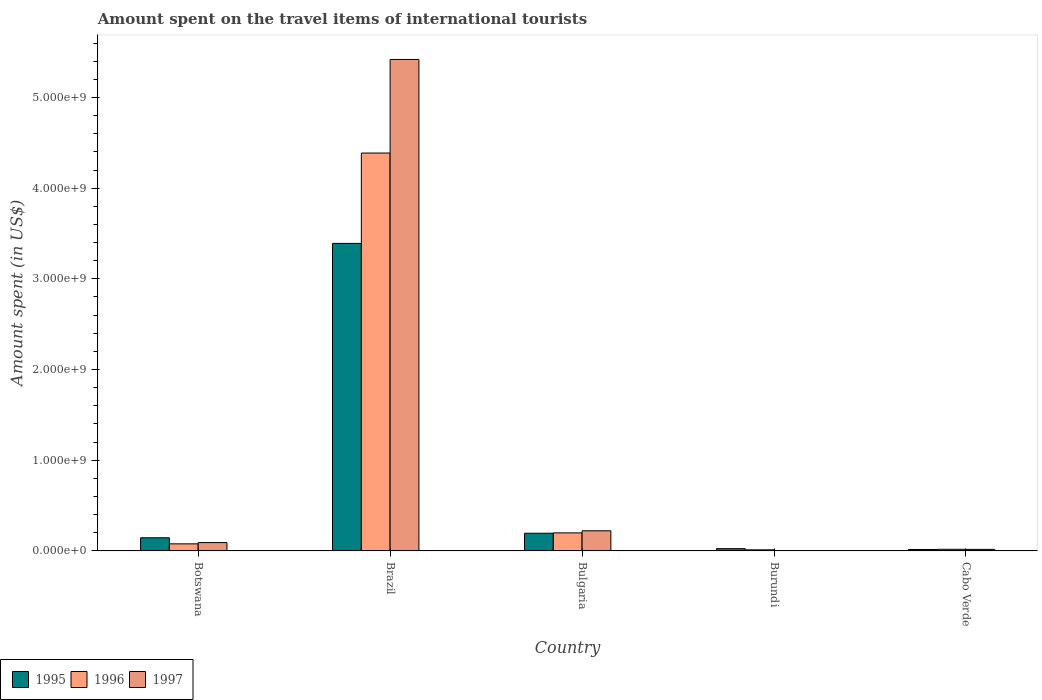How many different coloured bars are there?
Your answer should be very brief. 3. Are the number of bars on each tick of the X-axis equal?
Make the answer very short. Yes. What is the label of the 2nd group of bars from the left?
Ensure brevity in your answer.  Brazil. In how many cases, is the number of bars for a given country not equal to the number of legend labels?
Ensure brevity in your answer.  0. What is the amount spent on the travel items of international tourists in 1996 in Botswana?
Your answer should be compact. 7.80e+07. Across all countries, what is the maximum amount spent on the travel items of international tourists in 1995?
Your response must be concise. 3.39e+09. Across all countries, what is the minimum amount spent on the travel items of international tourists in 1995?
Provide a succinct answer. 1.60e+07. In which country was the amount spent on the travel items of international tourists in 1996 minimum?
Offer a terse response. Burundi. What is the total amount spent on the travel items of international tourists in 1997 in the graph?
Offer a very short reply. 5.75e+09. What is the difference between the amount spent on the travel items of international tourists in 1996 in Botswana and that in Bulgaria?
Your response must be concise. -1.21e+08. What is the difference between the amount spent on the travel items of international tourists in 1996 in Bulgaria and the amount spent on the travel items of international tourists in 1995 in Botswana?
Ensure brevity in your answer.  5.40e+07. What is the average amount spent on the travel items of international tourists in 1996 per country?
Your response must be concise. 9.39e+08. What is the difference between the amount spent on the travel items of international tourists of/in 1995 and amount spent on the travel items of international tourists of/in 1997 in Brazil?
Keep it short and to the point. -2.03e+09. In how many countries, is the amount spent on the travel items of international tourists in 1997 greater than 2600000000 US$?
Keep it short and to the point. 1. What is the difference between the highest and the second highest amount spent on the travel items of international tourists in 1996?
Your answer should be very brief. 4.31e+09. What is the difference between the highest and the lowest amount spent on the travel items of international tourists in 1995?
Your answer should be very brief. 3.38e+09. In how many countries, is the amount spent on the travel items of international tourists in 1997 greater than the average amount spent on the travel items of international tourists in 1997 taken over all countries?
Make the answer very short. 1. What does the 3rd bar from the right in Botswana represents?
Make the answer very short. 1995. Are all the bars in the graph horizontal?
Give a very brief answer. No. How many countries are there in the graph?
Your answer should be compact. 5. Are the values on the major ticks of Y-axis written in scientific E-notation?
Your response must be concise. Yes. How many legend labels are there?
Make the answer very short. 3. How are the legend labels stacked?
Your answer should be very brief. Horizontal. What is the title of the graph?
Offer a terse response. Amount spent on the travel items of international tourists. What is the label or title of the Y-axis?
Give a very brief answer. Amount spent (in US$). What is the Amount spent (in US$) of 1995 in Botswana?
Give a very brief answer. 1.45e+08. What is the Amount spent (in US$) in 1996 in Botswana?
Offer a very short reply. 7.80e+07. What is the Amount spent (in US$) in 1997 in Botswana?
Your answer should be very brief. 9.20e+07. What is the Amount spent (in US$) of 1995 in Brazil?
Make the answer very short. 3.39e+09. What is the Amount spent (in US$) of 1996 in Brazil?
Your answer should be compact. 4.39e+09. What is the Amount spent (in US$) in 1997 in Brazil?
Your response must be concise. 5.42e+09. What is the Amount spent (in US$) of 1995 in Bulgaria?
Keep it short and to the point. 1.95e+08. What is the Amount spent (in US$) in 1996 in Bulgaria?
Your answer should be very brief. 1.99e+08. What is the Amount spent (in US$) in 1997 in Bulgaria?
Make the answer very short. 2.22e+08. What is the Amount spent (in US$) of 1995 in Burundi?
Provide a short and direct response. 2.50e+07. What is the Amount spent (in US$) in 1996 in Burundi?
Offer a terse response. 1.20e+07. What is the Amount spent (in US$) in 1997 in Burundi?
Provide a short and direct response. 4.00e+06. What is the Amount spent (in US$) in 1995 in Cabo Verde?
Your response must be concise. 1.60e+07. What is the Amount spent (in US$) in 1996 in Cabo Verde?
Offer a very short reply. 1.80e+07. What is the Amount spent (in US$) in 1997 in Cabo Verde?
Keep it short and to the point. 1.70e+07. Across all countries, what is the maximum Amount spent (in US$) in 1995?
Provide a succinct answer. 3.39e+09. Across all countries, what is the maximum Amount spent (in US$) of 1996?
Your answer should be compact. 4.39e+09. Across all countries, what is the maximum Amount spent (in US$) of 1997?
Provide a short and direct response. 5.42e+09. Across all countries, what is the minimum Amount spent (in US$) of 1995?
Offer a terse response. 1.60e+07. Across all countries, what is the minimum Amount spent (in US$) in 1996?
Ensure brevity in your answer.  1.20e+07. Across all countries, what is the minimum Amount spent (in US$) in 1997?
Offer a very short reply. 4.00e+06. What is the total Amount spent (in US$) in 1995 in the graph?
Offer a very short reply. 3.77e+09. What is the total Amount spent (in US$) of 1996 in the graph?
Give a very brief answer. 4.69e+09. What is the total Amount spent (in US$) of 1997 in the graph?
Your response must be concise. 5.75e+09. What is the difference between the Amount spent (in US$) in 1995 in Botswana and that in Brazil?
Provide a succinct answer. -3.25e+09. What is the difference between the Amount spent (in US$) of 1996 in Botswana and that in Brazil?
Offer a very short reply. -4.31e+09. What is the difference between the Amount spent (in US$) in 1997 in Botswana and that in Brazil?
Provide a short and direct response. -5.33e+09. What is the difference between the Amount spent (in US$) of 1995 in Botswana and that in Bulgaria?
Your answer should be compact. -5.00e+07. What is the difference between the Amount spent (in US$) in 1996 in Botswana and that in Bulgaria?
Your answer should be compact. -1.21e+08. What is the difference between the Amount spent (in US$) in 1997 in Botswana and that in Bulgaria?
Your response must be concise. -1.30e+08. What is the difference between the Amount spent (in US$) of 1995 in Botswana and that in Burundi?
Offer a very short reply. 1.20e+08. What is the difference between the Amount spent (in US$) in 1996 in Botswana and that in Burundi?
Ensure brevity in your answer.  6.60e+07. What is the difference between the Amount spent (in US$) in 1997 in Botswana and that in Burundi?
Your answer should be very brief. 8.80e+07. What is the difference between the Amount spent (in US$) of 1995 in Botswana and that in Cabo Verde?
Keep it short and to the point. 1.29e+08. What is the difference between the Amount spent (in US$) in 1996 in Botswana and that in Cabo Verde?
Keep it short and to the point. 6.00e+07. What is the difference between the Amount spent (in US$) in 1997 in Botswana and that in Cabo Verde?
Make the answer very short. 7.50e+07. What is the difference between the Amount spent (in US$) in 1995 in Brazil and that in Bulgaria?
Your response must be concise. 3.20e+09. What is the difference between the Amount spent (in US$) of 1996 in Brazil and that in Bulgaria?
Provide a short and direct response. 4.19e+09. What is the difference between the Amount spent (in US$) of 1997 in Brazil and that in Bulgaria?
Your answer should be very brief. 5.20e+09. What is the difference between the Amount spent (in US$) in 1995 in Brazil and that in Burundi?
Keep it short and to the point. 3.37e+09. What is the difference between the Amount spent (in US$) of 1996 in Brazil and that in Burundi?
Provide a succinct answer. 4.38e+09. What is the difference between the Amount spent (in US$) in 1997 in Brazil and that in Burundi?
Provide a succinct answer. 5.42e+09. What is the difference between the Amount spent (in US$) in 1995 in Brazil and that in Cabo Verde?
Make the answer very short. 3.38e+09. What is the difference between the Amount spent (in US$) of 1996 in Brazil and that in Cabo Verde?
Make the answer very short. 4.37e+09. What is the difference between the Amount spent (in US$) in 1997 in Brazil and that in Cabo Verde?
Offer a terse response. 5.40e+09. What is the difference between the Amount spent (in US$) in 1995 in Bulgaria and that in Burundi?
Provide a succinct answer. 1.70e+08. What is the difference between the Amount spent (in US$) of 1996 in Bulgaria and that in Burundi?
Give a very brief answer. 1.87e+08. What is the difference between the Amount spent (in US$) of 1997 in Bulgaria and that in Burundi?
Make the answer very short. 2.18e+08. What is the difference between the Amount spent (in US$) in 1995 in Bulgaria and that in Cabo Verde?
Your response must be concise. 1.79e+08. What is the difference between the Amount spent (in US$) of 1996 in Bulgaria and that in Cabo Verde?
Ensure brevity in your answer.  1.81e+08. What is the difference between the Amount spent (in US$) in 1997 in Bulgaria and that in Cabo Verde?
Your answer should be very brief. 2.05e+08. What is the difference between the Amount spent (in US$) in 1995 in Burundi and that in Cabo Verde?
Make the answer very short. 9.00e+06. What is the difference between the Amount spent (in US$) of 1996 in Burundi and that in Cabo Verde?
Make the answer very short. -6.00e+06. What is the difference between the Amount spent (in US$) of 1997 in Burundi and that in Cabo Verde?
Offer a terse response. -1.30e+07. What is the difference between the Amount spent (in US$) in 1995 in Botswana and the Amount spent (in US$) in 1996 in Brazil?
Provide a short and direct response. -4.24e+09. What is the difference between the Amount spent (in US$) in 1995 in Botswana and the Amount spent (in US$) in 1997 in Brazil?
Your answer should be very brief. -5.27e+09. What is the difference between the Amount spent (in US$) in 1996 in Botswana and the Amount spent (in US$) in 1997 in Brazil?
Your response must be concise. -5.34e+09. What is the difference between the Amount spent (in US$) of 1995 in Botswana and the Amount spent (in US$) of 1996 in Bulgaria?
Provide a succinct answer. -5.40e+07. What is the difference between the Amount spent (in US$) of 1995 in Botswana and the Amount spent (in US$) of 1997 in Bulgaria?
Your answer should be very brief. -7.70e+07. What is the difference between the Amount spent (in US$) in 1996 in Botswana and the Amount spent (in US$) in 1997 in Bulgaria?
Offer a very short reply. -1.44e+08. What is the difference between the Amount spent (in US$) in 1995 in Botswana and the Amount spent (in US$) in 1996 in Burundi?
Offer a very short reply. 1.33e+08. What is the difference between the Amount spent (in US$) in 1995 in Botswana and the Amount spent (in US$) in 1997 in Burundi?
Keep it short and to the point. 1.41e+08. What is the difference between the Amount spent (in US$) of 1996 in Botswana and the Amount spent (in US$) of 1997 in Burundi?
Keep it short and to the point. 7.40e+07. What is the difference between the Amount spent (in US$) in 1995 in Botswana and the Amount spent (in US$) in 1996 in Cabo Verde?
Keep it short and to the point. 1.27e+08. What is the difference between the Amount spent (in US$) in 1995 in Botswana and the Amount spent (in US$) in 1997 in Cabo Verde?
Provide a succinct answer. 1.28e+08. What is the difference between the Amount spent (in US$) in 1996 in Botswana and the Amount spent (in US$) in 1997 in Cabo Verde?
Provide a succinct answer. 6.10e+07. What is the difference between the Amount spent (in US$) of 1995 in Brazil and the Amount spent (in US$) of 1996 in Bulgaria?
Provide a short and direct response. 3.19e+09. What is the difference between the Amount spent (in US$) of 1995 in Brazil and the Amount spent (in US$) of 1997 in Bulgaria?
Offer a very short reply. 3.17e+09. What is the difference between the Amount spent (in US$) in 1996 in Brazil and the Amount spent (in US$) in 1997 in Bulgaria?
Keep it short and to the point. 4.16e+09. What is the difference between the Amount spent (in US$) in 1995 in Brazil and the Amount spent (in US$) in 1996 in Burundi?
Keep it short and to the point. 3.38e+09. What is the difference between the Amount spent (in US$) of 1995 in Brazil and the Amount spent (in US$) of 1997 in Burundi?
Offer a very short reply. 3.39e+09. What is the difference between the Amount spent (in US$) in 1996 in Brazil and the Amount spent (in US$) in 1997 in Burundi?
Your answer should be very brief. 4.38e+09. What is the difference between the Amount spent (in US$) in 1995 in Brazil and the Amount spent (in US$) in 1996 in Cabo Verde?
Provide a short and direct response. 3.37e+09. What is the difference between the Amount spent (in US$) in 1995 in Brazil and the Amount spent (in US$) in 1997 in Cabo Verde?
Your answer should be compact. 3.37e+09. What is the difference between the Amount spent (in US$) of 1996 in Brazil and the Amount spent (in US$) of 1997 in Cabo Verde?
Your response must be concise. 4.37e+09. What is the difference between the Amount spent (in US$) in 1995 in Bulgaria and the Amount spent (in US$) in 1996 in Burundi?
Provide a succinct answer. 1.83e+08. What is the difference between the Amount spent (in US$) of 1995 in Bulgaria and the Amount spent (in US$) of 1997 in Burundi?
Make the answer very short. 1.91e+08. What is the difference between the Amount spent (in US$) in 1996 in Bulgaria and the Amount spent (in US$) in 1997 in Burundi?
Your answer should be compact. 1.95e+08. What is the difference between the Amount spent (in US$) of 1995 in Bulgaria and the Amount spent (in US$) of 1996 in Cabo Verde?
Offer a terse response. 1.77e+08. What is the difference between the Amount spent (in US$) in 1995 in Bulgaria and the Amount spent (in US$) in 1997 in Cabo Verde?
Your answer should be compact. 1.78e+08. What is the difference between the Amount spent (in US$) of 1996 in Bulgaria and the Amount spent (in US$) of 1997 in Cabo Verde?
Make the answer very short. 1.82e+08. What is the difference between the Amount spent (in US$) in 1995 in Burundi and the Amount spent (in US$) in 1996 in Cabo Verde?
Offer a very short reply. 7.00e+06. What is the difference between the Amount spent (in US$) in 1995 in Burundi and the Amount spent (in US$) in 1997 in Cabo Verde?
Ensure brevity in your answer.  8.00e+06. What is the difference between the Amount spent (in US$) of 1996 in Burundi and the Amount spent (in US$) of 1997 in Cabo Verde?
Provide a short and direct response. -5.00e+06. What is the average Amount spent (in US$) in 1995 per country?
Your answer should be very brief. 7.54e+08. What is the average Amount spent (in US$) in 1996 per country?
Offer a terse response. 9.39e+08. What is the average Amount spent (in US$) in 1997 per country?
Give a very brief answer. 1.15e+09. What is the difference between the Amount spent (in US$) in 1995 and Amount spent (in US$) in 1996 in Botswana?
Keep it short and to the point. 6.70e+07. What is the difference between the Amount spent (in US$) in 1995 and Amount spent (in US$) in 1997 in Botswana?
Your answer should be very brief. 5.30e+07. What is the difference between the Amount spent (in US$) of 1996 and Amount spent (in US$) of 1997 in Botswana?
Your answer should be compact. -1.40e+07. What is the difference between the Amount spent (in US$) in 1995 and Amount spent (in US$) in 1996 in Brazil?
Your response must be concise. -9.96e+08. What is the difference between the Amount spent (in US$) in 1995 and Amount spent (in US$) in 1997 in Brazil?
Your answer should be very brief. -2.03e+09. What is the difference between the Amount spent (in US$) of 1996 and Amount spent (in US$) of 1997 in Brazil?
Offer a terse response. -1.03e+09. What is the difference between the Amount spent (in US$) in 1995 and Amount spent (in US$) in 1997 in Bulgaria?
Your response must be concise. -2.70e+07. What is the difference between the Amount spent (in US$) in 1996 and Amount spent (in US$) in 1997 in Bulgaria?
Make the answer very short. -2.30e+07. What is the difference between the Amount spent (in US$) in 1995 and Amount spent (in US$) in 1996 in Burundi?
Provide a succinct answer. 1.30e+07. What is the difference between the Amount spent (in US$) of 1995 and Amount spent (in US$) of 1997 in Burundi?
Offer a very short reply. 2.10e+07. What is the difference between the Amount spent (in US$) in 1996 and Amount spent (in US$) in 1997 in Burundi?
Provide a succinct answer. 8.00e+06. What is the difference between the Amount spent (in US$) of 1995 and Amount spent (in US$) of 1996 in Cabo Verde?
Your answer should be very brief. -2.00e+06. What is the difference between the Amount spent (in US$) in 1996 and Amount spent (in US$) in 1997 in Cabo Verde?
Your answer should be very brief. 1.00e+06. What is the ratio of the Amount spent (in US$) in 1995 in Botswana to that in Brazil?
Your response must be concise. 0.04. What is the ratio of the Amount spent (in US$) of 1996 in Botswana to that in Brazil?
Your answer should be very brief. 0.02. What is the ratio of the Amount spent (in US$) of 1997 in Botswana to that in Brazil?
Provide a short and direct response. 0.02. What is the ratio of the Amount spent (in US$) of 1995 in Botswana to that in Bulgaria?
Give a very brief answer. 0.74. What is the ratio of the Amount spent (in US$) of 1996 in Botswana to that in Bulgaria?
Ensure brevity in your answer.  0.39. What is the ratio of the Amount spent (in US$) in 1997 in Botswana to that in Bulgaria?
Your answer should be compact. 0.41. What is the ratio of the Amount spent (in US$) in 1996 in Botswana to that in Burundi?
Your response must be concise. 6.5. What is the ratio of the Amount spent (in US$) of 1995 in Botswana to that in Cabo Verde?
Provide a succinct answer. 9.06. What is the ratio of the Amount spent (in US$) of 1996 in Botswana to that in Cabo Verde?
Your answer should be compact. 4.33. What is the ratio of the Amount spent (in US$) in 1997 in Botswana to that in Cabo Verde?
Your answer should be compact. 5.41. What is the ratio of the Amount spent (in US$) of 1995 in Brazil to that in Bulgaria?
Offer a very short reply. 17.39. What is the ratio of the Amount spent (in US$) of 1996 in Brazil to that in Bulgaria?
Ensure brevity in your answer.  22.05. What is the ratio of the Amount spent (in US$) of 1997 in Brazil to that in Bulgaria?
Offer a very short reply. 24.41. What is the ratio of the Amount spent (in US$) of 1995 in Brazil to that in Burundi?
Your answer should be compact. 135.64. What is the ratio of the Amount spent (in US$) of 1996 in Brazil to that in Burundi?
Give a very brief answer. 365.58. What is the ratio of the Amount spent (in US$) in 1997 in Brazil to that in Burundi?
Make the answer very short. 1354.75. What is the ratio of the Amount spent (in US$) in 1995 in Brazil to that in Cabo Verde?
Provide a succinct answer. 211.94. What is the ratio of the Amount spent (in US$) in 1996 in Brazil to that in Cabo Verde?
Provide a succinct answer. 243.72. What is the ratio of the Amount spent (in US$) of 1997 in Brazil to that in Cabo Verde?
Provide a succinct answer. 318.76. What is the ratio of the Amount spent (in US$) in 1995 in Bulgaria to that in Burundi?
Provide a succinct answer. 7.8. What is the ratio of the Amount spent (in US$) of 1996 in Bulgaria to that in Burundi?
Ensure brevity in your answer.  16.58. What is the ratio of the Amount spent (in US$) in 1997 in Bulgaria to that in Burundi?
Offer a terse response. 55.5. What is the ratio of the Amount spent (in US$) in 1995 in Bulgaria to that in Cabo Verde?
Your response must be concise. 12.19. What is the ratio of the Amount spent (in US$) in 1996 in Bulgaria to that in Cabo Verde?
Ensure brevity in your answer.  11.06. What is the ratio of the Amount spent (in US$) of 1997 in Bulgaria to that in Cabo Verde?
Keep it short and to the point. 13.06. What is the ratio of the Amount spent (in US$) in 1995 in Burundi to that in Cabo Verde?
Provide a short and direct response. 1.56. What is the ratio of the Amount spent (in US$) in 1996 in Burundi to that in Cabo Verde?
Keep it short and to the point. 0.67. What is the ratio of the Amount spent (in US$) of 1997 in Burundi to that in Cabo Verde?
Your answer should be compact. 0.24. What is the difference between the highest and the second highest Amount spent (in US$) in 1995?
Provide a succinct answer. 3.20e+09. What is the difference between the highest and the second highest Amount spent (in US$) of 1996?
Your answer should be very brief. 4.19e+09. What is the difference between the highest and the second highest Amount spent (in US$) in 1997?
Offer a very short reply. 5.20e+09. What is the difference between the highest and the lowest Amount spent (in US$) in 1995?
Provide a succinct answer. 3.38e+09. What is the difference between the highest and the lowest Amount spent (in US$) in 1996?
Your answer should be compact. 4.38e+09. What is the difference between the highest and the lowest Amount spent (in US$) in 1997?
Keep it short and to the point. 5.42e+09. 